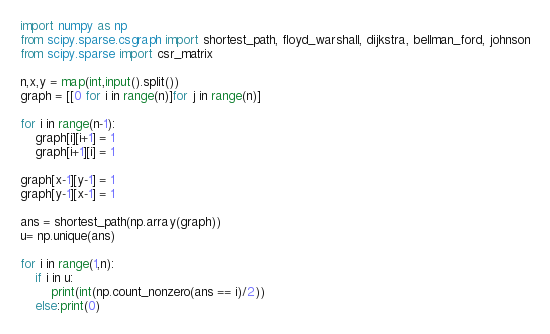Convert code to text. <code><loc_0><loc_0><loc_500><loc_500><_Python_>import numpy as np
from scipy.sparse.csgraph import shortest_path, floyd_warshall, dijkstra, bellman_ford, johnson
from scipy.sparse import csr_matrix

n,x,y = map(int,input().split())
graph = [[0 for i in range(n)]for j in range(n)]

for i in range(n-1):
    graph[i][i+1] = 1
    graph[i+1][i] = 1
    
graph[x-1][y-1] = 1
graph[y-1][x-1] = 1

ans = shortest_path(np.array(graph))
u= np.unique(ans)

for i in range(1,n):
    if i in u:
        print(int(np.count_nonzero(ans == i)/2))
    else:print(0)</code> 